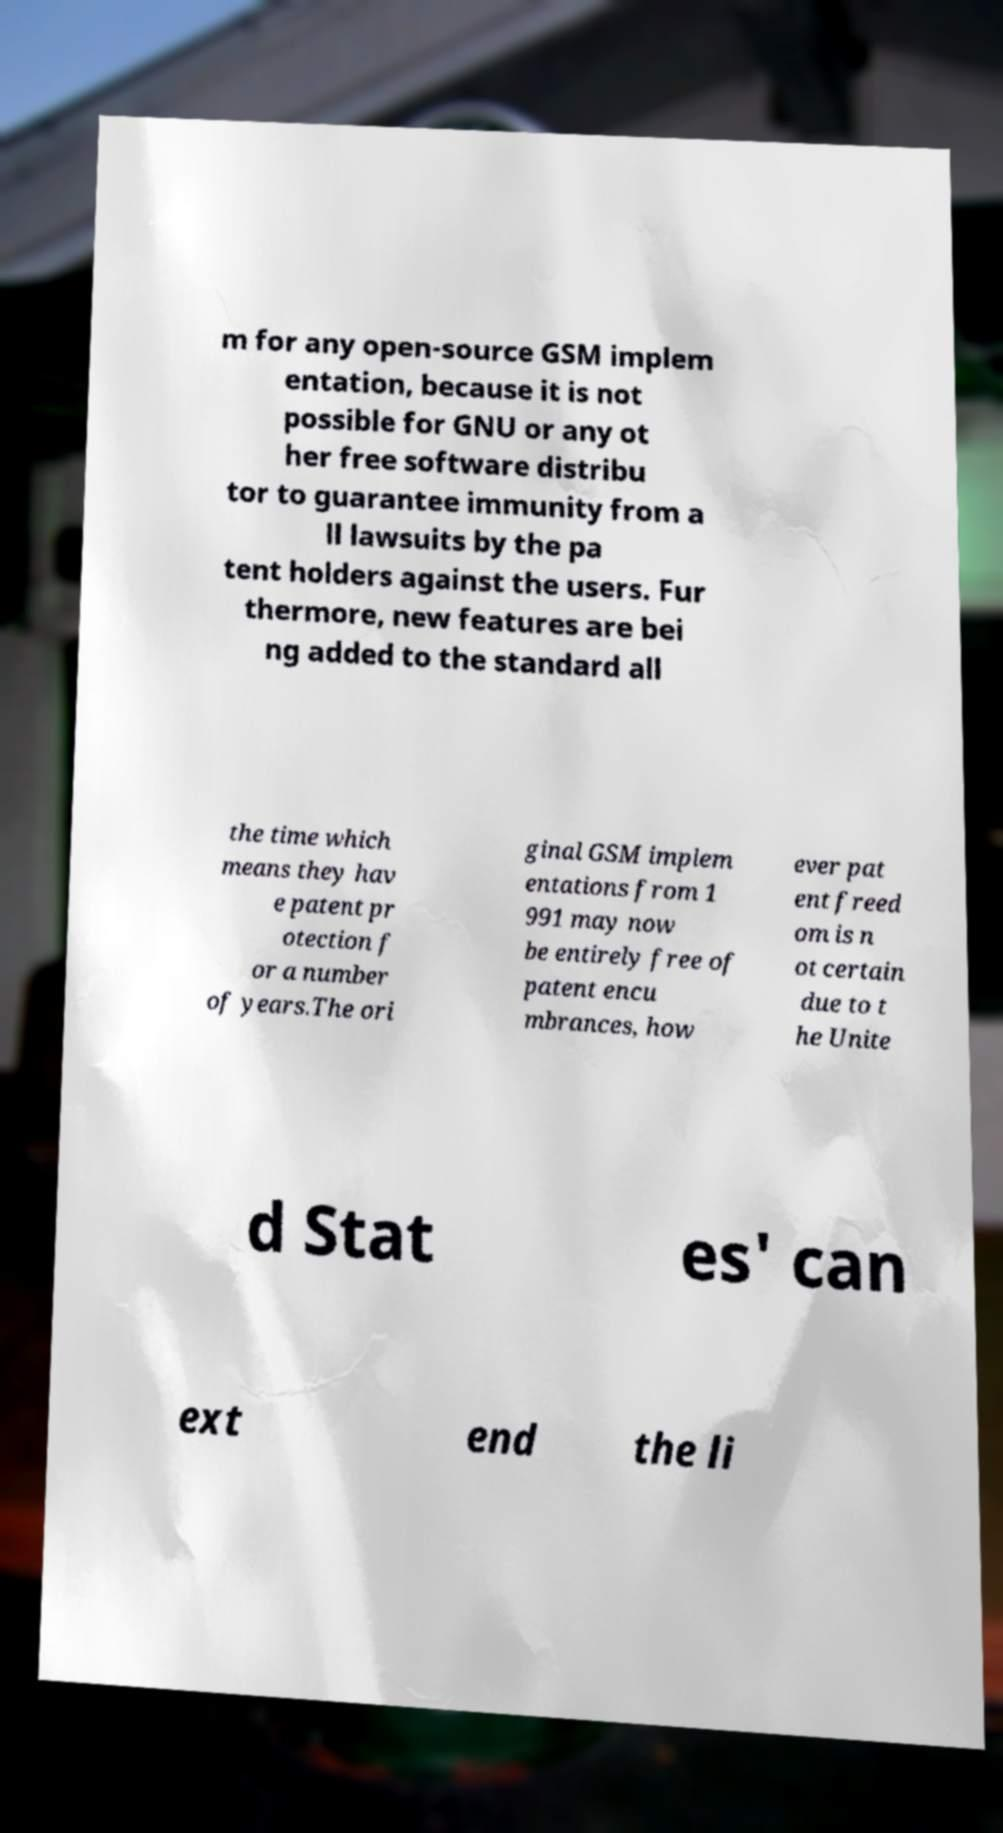For documentation purposes, I need the text within this image transcribed. Could you provide that? m for any open-source GSM implem entation, because it is not possible for GNU or any ot her free software distribu tor to guarantee immunity from a ll lawsuits by the pa tent holders against the users. Fur thermore, new features are bei ng added to the standard all the time which means they hav e patent pr otection f or a number of years.The ori ginal GSM implem entations from 1 991 may now be entirely free of patent encu mbrances, how ever pat ent freed om is n ot certain due to t he Unite d Stat es' can ext end the li 